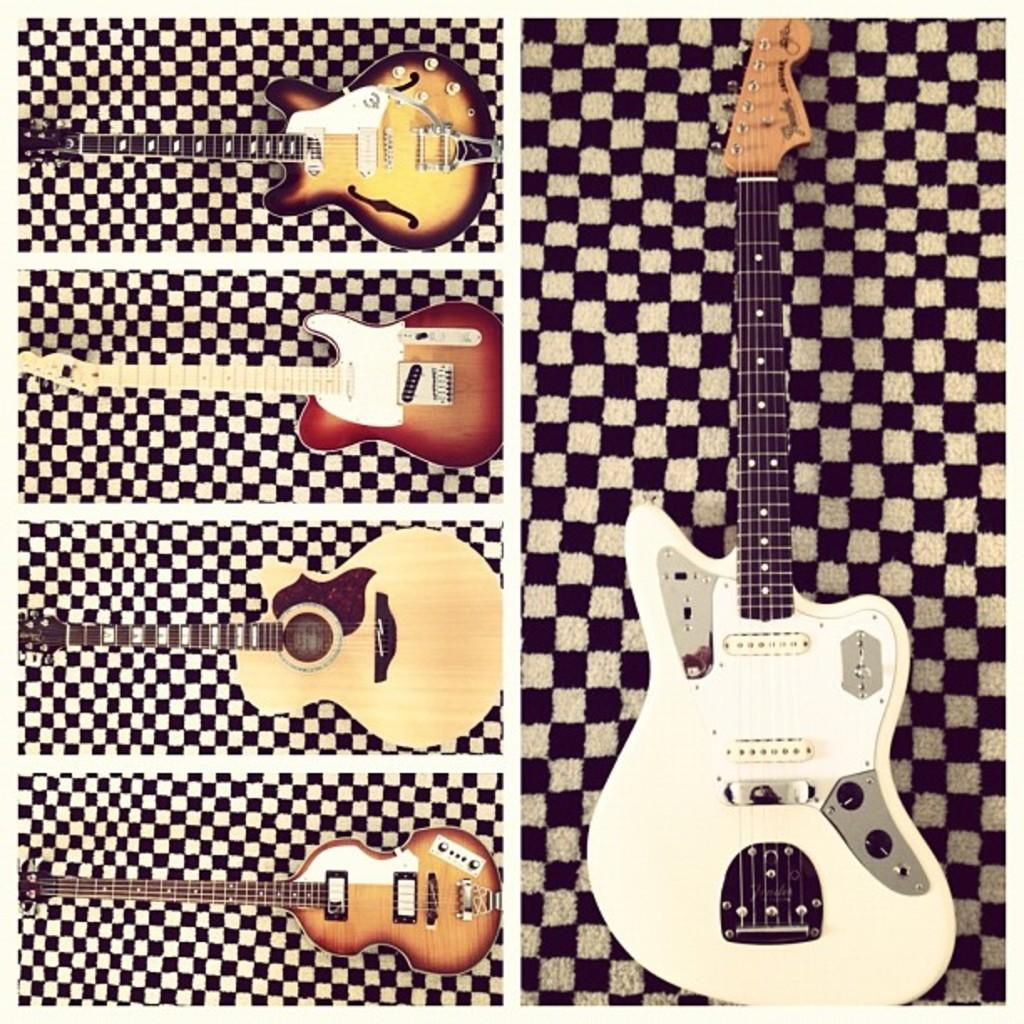How many guitars are present in the image? There are five guitars in the image. What type of request can be seen written on the library wall in the image? There is no library or request present in the image; it only features five guitars. 